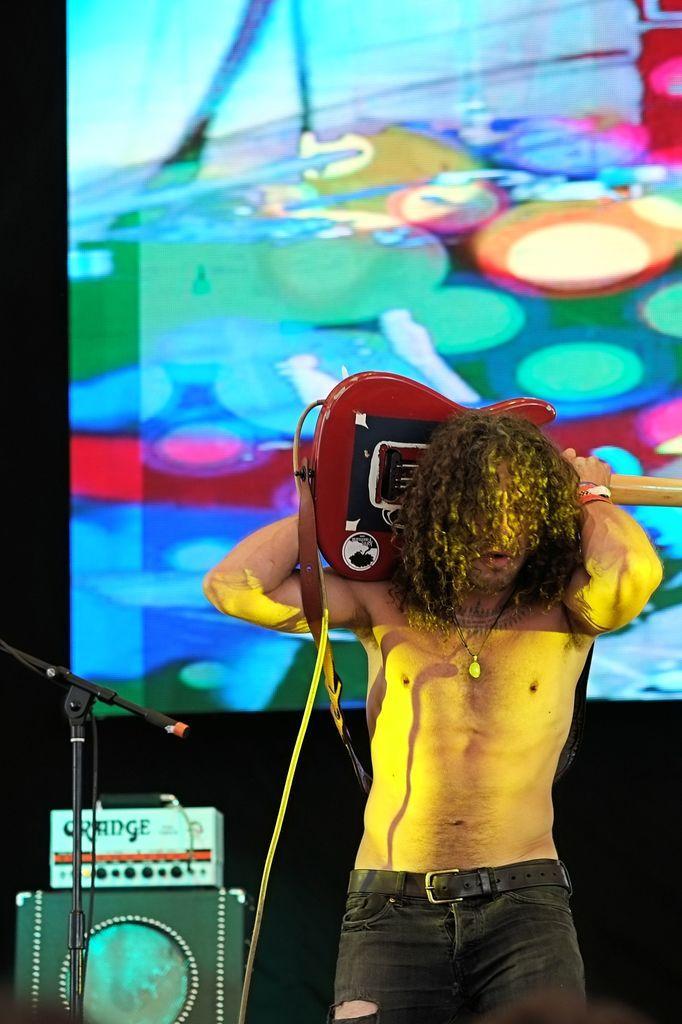Can you describe this image briefly? In this image we can see a person standing and holding a guitar, beside him there is a microphone stand and a few other objects, behind him there is a screen. 